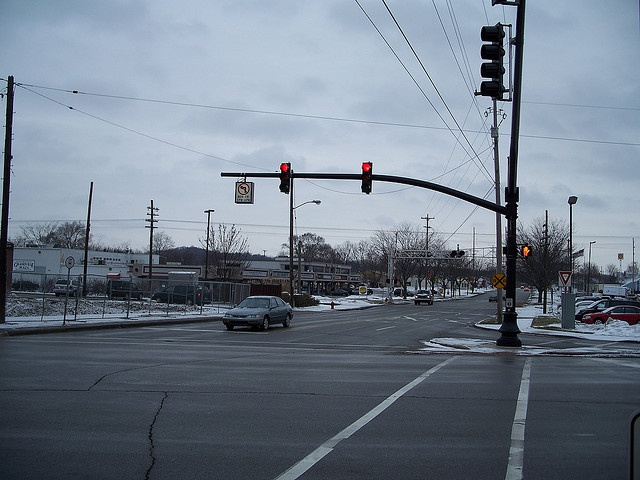Describe the objects in this image and their specific colors. I can see car in gray, black, and blue tones, traffic light in gray, black, lightgray, and darkgray tones, car in gray, black, and darkblue tones, car in gray, black, maroon, and darkgray tones, and car in gray, black, and darkblue tones in this image. 